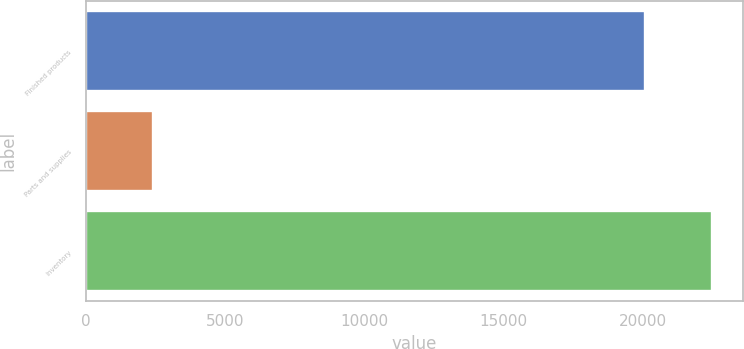<chart> <loc_0><loc_0><loc_500><loc_500><bar_chart><fcel>Finished products<fcel>Parts and supplies<fcel>Inventory<nl><fcel>20076<fcel>2401<fcel>22477<nl></chart> 